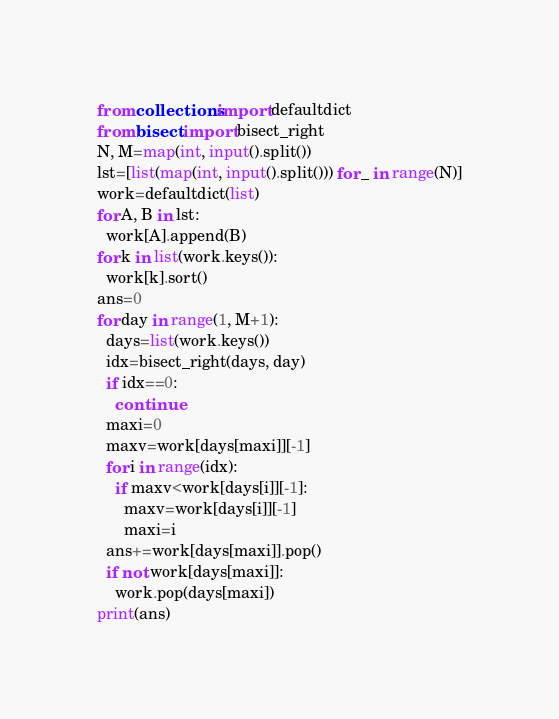<code> <loc_0><loc_0><loc_500><loc_500><_Python_>from collections import defaultdict
from bisect import bisect_right
N, M=map(int, input().split())
lst=[list(map(int, input().split())) for _ in range(N)]
work=defaultdict(list)
for A, B in lst:
  work[A].append(B)
for k in list(work.keys()):
  work[k].sort()
ans=0
for day in range(1, M+1):
  days=list(work.keys())
  idx=bisect_right(days, day)
  if idx==0:
    continue
  maxi=0
  maxv=work[days[maxi]][-1]
  for i in range(idx):
    if maxv<work[days[i]][-1]:
      maxv=work[days[i]][-1]
      maxi=i
  ans+=work[days[maxi]].pop()
  if not work[days[maxi]]:
    work.pop(days[maxi])
print(ans)</code> 